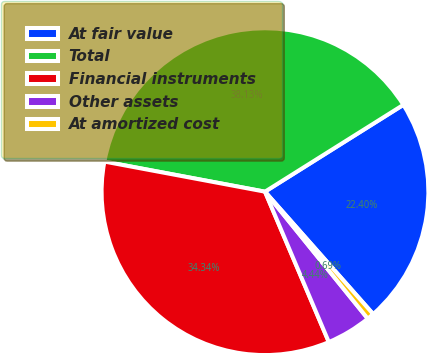<chart> <loc_0><loc_0><loc_500><loc_500><pie_chart><fcel>At fair value<fcel>Total<fcel>Financial instruments<fcel>Other assets<fcel>At amortized cost<nl><fcel>22.4%<fcel>38.13%<fcel>34.34%<fcel>4.44%<fcel>0.69%<nl></chart> 